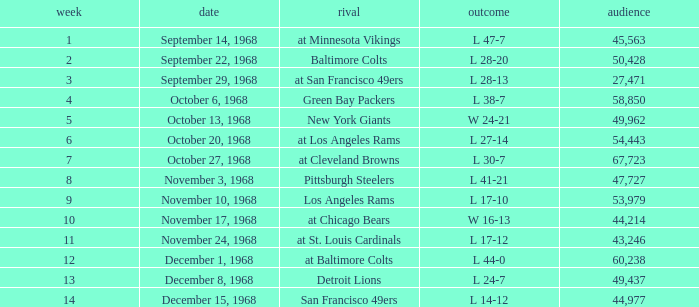I'm looking to parse the entire table for insights. Could you assist me with that? {'header': ['week', 'date', 'rival', 'outcome', 'audience'], 'rows': [['1', 'September 14, 1968', 'at Minnesota Vikings', 'L 47-7', '45,563'], ['2', 'September 22, 1968', 'Baltimore Colts', 'L 28-20', '50,428'], ['3', 'September 29, 1968', 'at San Francisco 49ers', 'L 28-13', '27,471'], ['4', 'October 6, 1968', 'Green Bay Packers', 'L 38-7', '58,850'], ['5', 'October 13, 1968', 'New York Giants', 'W 24-21', '49,962'], ['6', 'October 20, 1968', 'at Los Angeles Rams', 'L 27-14', '54,443'], ['7', 'October 27, 1968', 'at Cleveland Browns', 'L 30-7', '67,723'], ['8', 'November 3, 1968', 'Pittsburgh Steelers', 'L 41-21', '47,727'], ['9', 'November 10, 1968', 'Los Angeles Rams', 'L 17-10', '53,979'], ['10', 'November 17, 1968', 'at Chicago Bears', 'W 16-13', '44,214'], ['11', 'November 24, 1968', 'at St. Louis Cardinals', 'L 17-12', '43,246'], ['12', 'December 1, 1968', 'at Baltimore Colts', 'L 44-0', '60,238'], ['13', 'December 8, 1968', 'Detroit Lions', 'L 24-7', '49,437'], ['14', 'December 15, 1968', 'San Francisco 49ers', 'L 14-12', '44,977']]} Which Attendance has a Date of september 29, 1968, and a Week smaller than 3? None. 